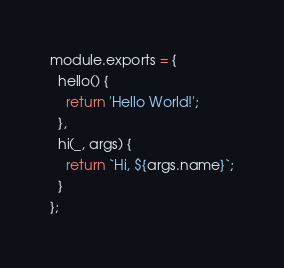Convert code to text. <code><loc_0><loc_0><loc_500><loc_500><_JavaScript_>module.exports = {
  hello() {
    return 'Hello World!';
  },
  hi(_, args) {
    return `Hi, ${args.name}`;
  }
};
</code> 